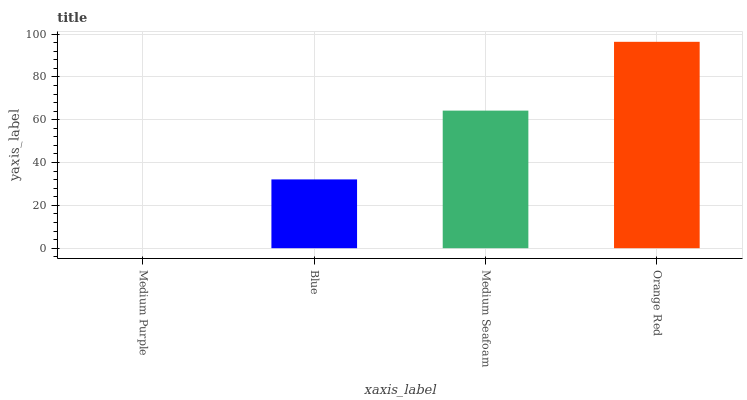Is Medium Purple the minimum?
Answer yes or no. Yes. Is Orange Red the maximum?
Answer yes or no. Yes. Is Blue the minimum?
Answer yes or no. No. Is Blue the maximum?
Answer yes or no. No. Is Blue greater than Medium Purple?
Answer yes or no. Yes. Is Medium Purple less than Blue?
Answer yes or no. Yes. Is Medium Purple greater than Blue?
Answer yes or no. No. Is Blue less than Medium Purple?
Answer yes or no. No. Is Medium Seafoam the high median?
Answer yes or no. Yes. Is Blue the low median?
Answer yes or no. Yes. Is Orange Red the high median?
Answer yes or no. No. Is Medium Seafoam the low median?
Answer yes or no. No. 